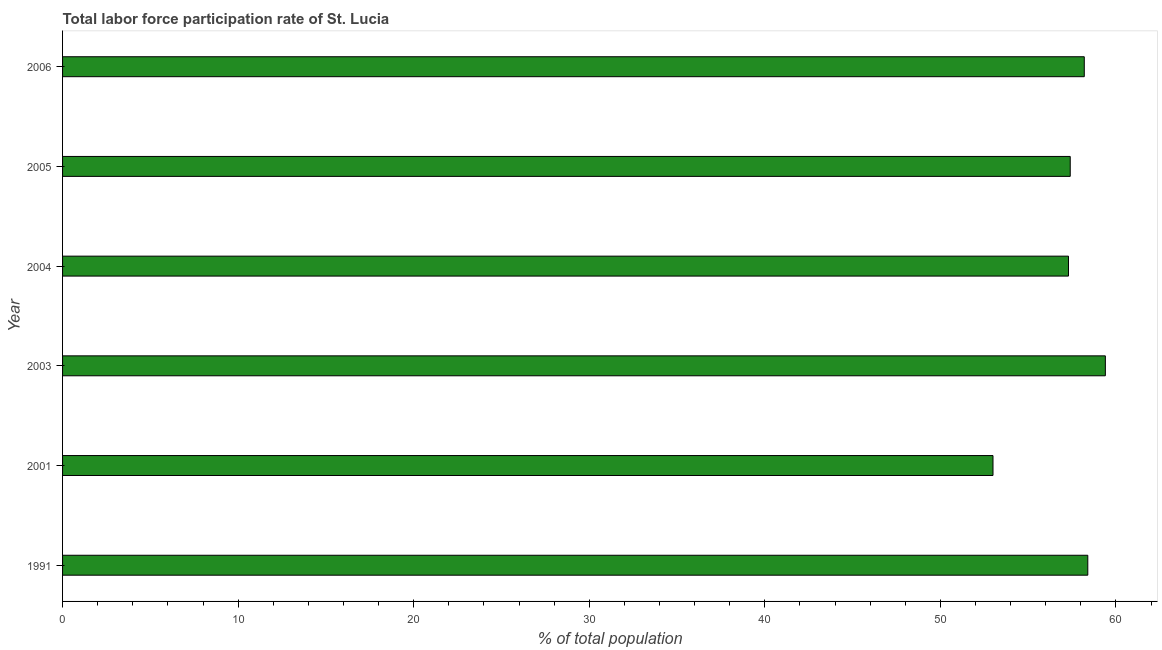Does the graph contain any zero values?
Offer a terse response. No. What is the title of the graph?
Offer a terse response. Total labor force participation rate of St. Lucia. What is the label or title of the X-axis?
Ensure brevity in your answer.  % of total population. What is the total labor force participation rate in 1991?
Offer a terse response. 58.4. Across all years, what is the maximum total labor force participation rate?
Ensure brevity in your answer.  59.4. In which year was the total labor force participation rate maximum?
Offer a terse response. 2003. In which year was the total labor force participation rate minimum?
Your response must be concise. 2001. What is the sum of the total labor force participation rate?
Ensure brevity in your answer.  343.7. What is the average total labor force participation rate per year?
Keep it short and to the point. 57.28. What is the median total labor force participation rate?
Your response must be concise. 57.8. In how many years, is the total labor force participation rate greater than 56 %?
Provide a short and direct response. 5. Do a majority of the years between 2003 and 2006 (inclusive) have total labor force participation rate greater than 18 %?
Give a very brief answer. Yes. Is the total labor force participation rate in 2001 less than that in 2003?
Provide a succinct answer. Yes. What is the difference between the highest and the lowest total labor force participation rate?
Ensure brevity in your answer.  6.4. How many years are there in the graph?
Your response must be concise. 6. What is the difference between two consecutive major ticks on the X-axis?
Give a very brief answer. 10. Are the values on the major ticks of X-axis written in scientific E-notation?
Offer a very short reply. No. What is the % of total population in 1991?
Your response must be concise. 58.4. What is the % of total population in 2001?
Ensure brevity in your answer.  53. What is the % of total population of 2003?
Your response must be concise. 59.4. What is the % of total population in 2004?
Give a very brief answer. 57.3. What is the % of total population in 2005?
Provide a succinct answer. 57.4. What is the % of total population in 2006?
Offer a terse response. 58.2. What is the difference between the % of total population in 1991 and 2001?
Your answer should be compact. 5.4. What is the difference between the % of total population in 1991 and 2003?
Keep it short and to the point. -1. What is the difference between the % of total population in 1991 and 2004?
Provide a short and direct response. 1.1. What is the difference between the % of total population in 1991 and 2005?
Make the answer very short. 1. What is the difference between the % of total population in 1991 and 2006?
Ensure brevity in your answer.  0.2. What is the difference between the % of total population in 2001 and 2003?
Your response must be concise. -6.4. What is the difference between the % of total population in 2003 and 2005?
Offer a terse response. 2. What is the difference between the % of total population in 2004 and 2005?
Make the answer very short. -0.1. What is the ratio of the % of total population in 1991 to that in 2001?
Your answer should be compact. 1.1. What is the ratio of the % of total population in 1991 to that in 2003?
Offer a very short reply. 0.98. What is the ratio of the % of total population in 1991 to that in 2006?
Offer a terse response. 1. What is the ratio of the % of total population in 2001 to that in 2003?
Ensure brevity in your answer.  0.89. What is the ratio of the % of total population in 2001 to that in 2004?
Keep it short and to the point. 0.93. What is the ratio of the % of total population in 2001 to that in 2005?
Your answer should be compact. 0.92. What is the ratio of the % of total population in 2001 to that in 2006?
Keep it short and to the point. 0.91. What is the ratio of the % of total population in 2003 to that in 2005?
Make the answer very short. 1.03. What is the ratio of the % of total population in 2003 to that in 2006?
Your answer should be very brief. 1.02. What is the ratio of the % of total population in 2004 to that in 2006?
Ensure brevity in your answer.  0.98. What is the ratio of the % of total population in 2005 to that in 2006?
Give a very brief answer. 0.99. 